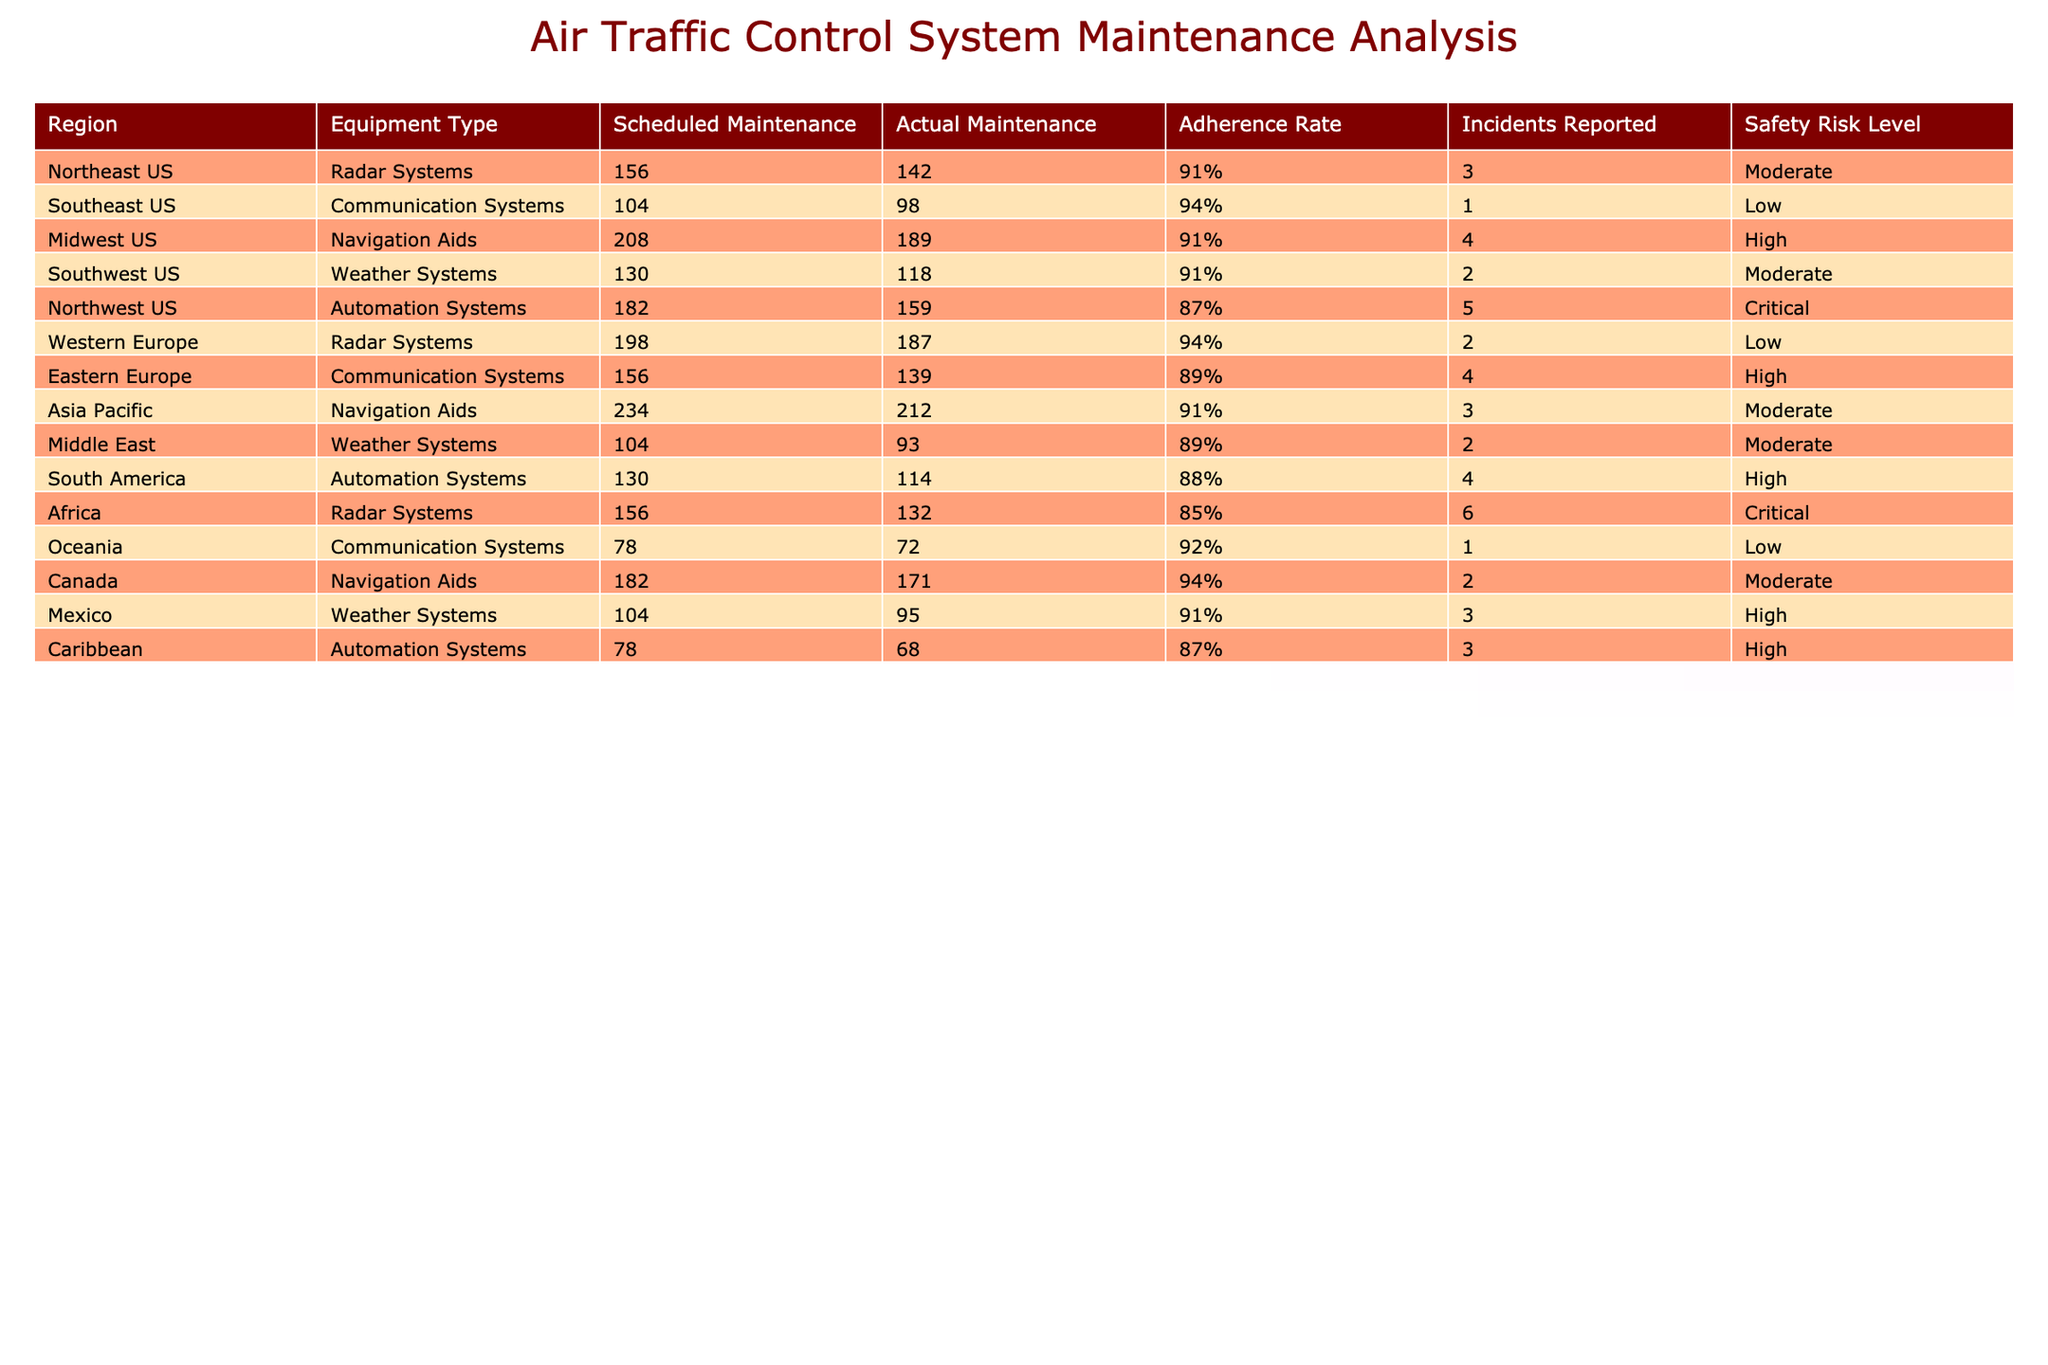What is the adherence rate for Automation Systems in the Northwest US? The adherence rate for Automation Systems in the Northwest US is shown in the table under the "Adherence Rate" column. It is listed as 87%.
Answer: 87% Which region has the highest number of incidents reported? By examining the "Incidents Reported" column, I can see that Africa has the highest number of incidents with 6 reported.
Answer: 6 Is the safety risk level for Weather Systems in the Middle East classified as High? Checking the "Safety Risk Level" column for Weather Systems in the Middle East, it is noted as Moderate, so the statement is false.
Answer: No What is the difference in adherence rates between Radar Systems in Africa and Western Europe? The adherence rate for Radar Systems in Africa is 85%, while in Western Europe it is 94%. The difference is 94% - 85% = 9%.
Answer: 9% What is the average adherence rate for all regions listed in the table? To find the average adherence rate, I will add up all the adherence rates: (91% + 94% + 91% + 91% + 87% + 94% + 89% + 91% + 89% + 88% + 85% + 92% + 94% + 91% + 87%)/15 = 90.27%.
Answer: 90.27% Which equipment type has the lowest adherence rate and what is that rate? Looking at the "Adherence Rate" column, I find that Automation Systems in Africa has the lowest adherence rate at 85%.
Answer: Automation Systems, 85% Is there any region where the adherence rate for Communication Systems is above 90%? Checking the table, I see that Oceania has an adherence rate of 92% for Communication Systems, so yes, there is such a region.
Answer: Yes If I sum up the number of incidents reported across all regions, what is the total? Adding all reported incidents: 3 + 1 + 4 + 2 + 5 + 2 + 4 + 3 + 2 + 4 + 6 + 1 + 2 + 3 + 3 = 43.
Answer: 43 How many regions have an adherence rate below 90%? I will count the occurrences of adherence rates below 90% in the table: Northwest US, Eastern Europe, Middle East, South America, and Africa. That's 5 regions in total.
Answer: 5 What is the safety risk level for Navigation Aids in Canada? The safety risk level listed for Navigation Aids in Canada in the table is Moderate.
Answer: Moderate Are there any regions where the adherence rate for Weather Systems is greater than 90%? In the table, the adherence rates for Weather Systems are 91% (Southwest US) and 91% (Mexico), so there are regions with an adherence rate greater than 90%.
Answer: Yes 